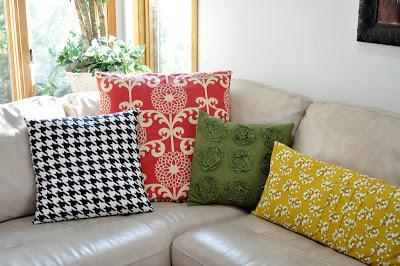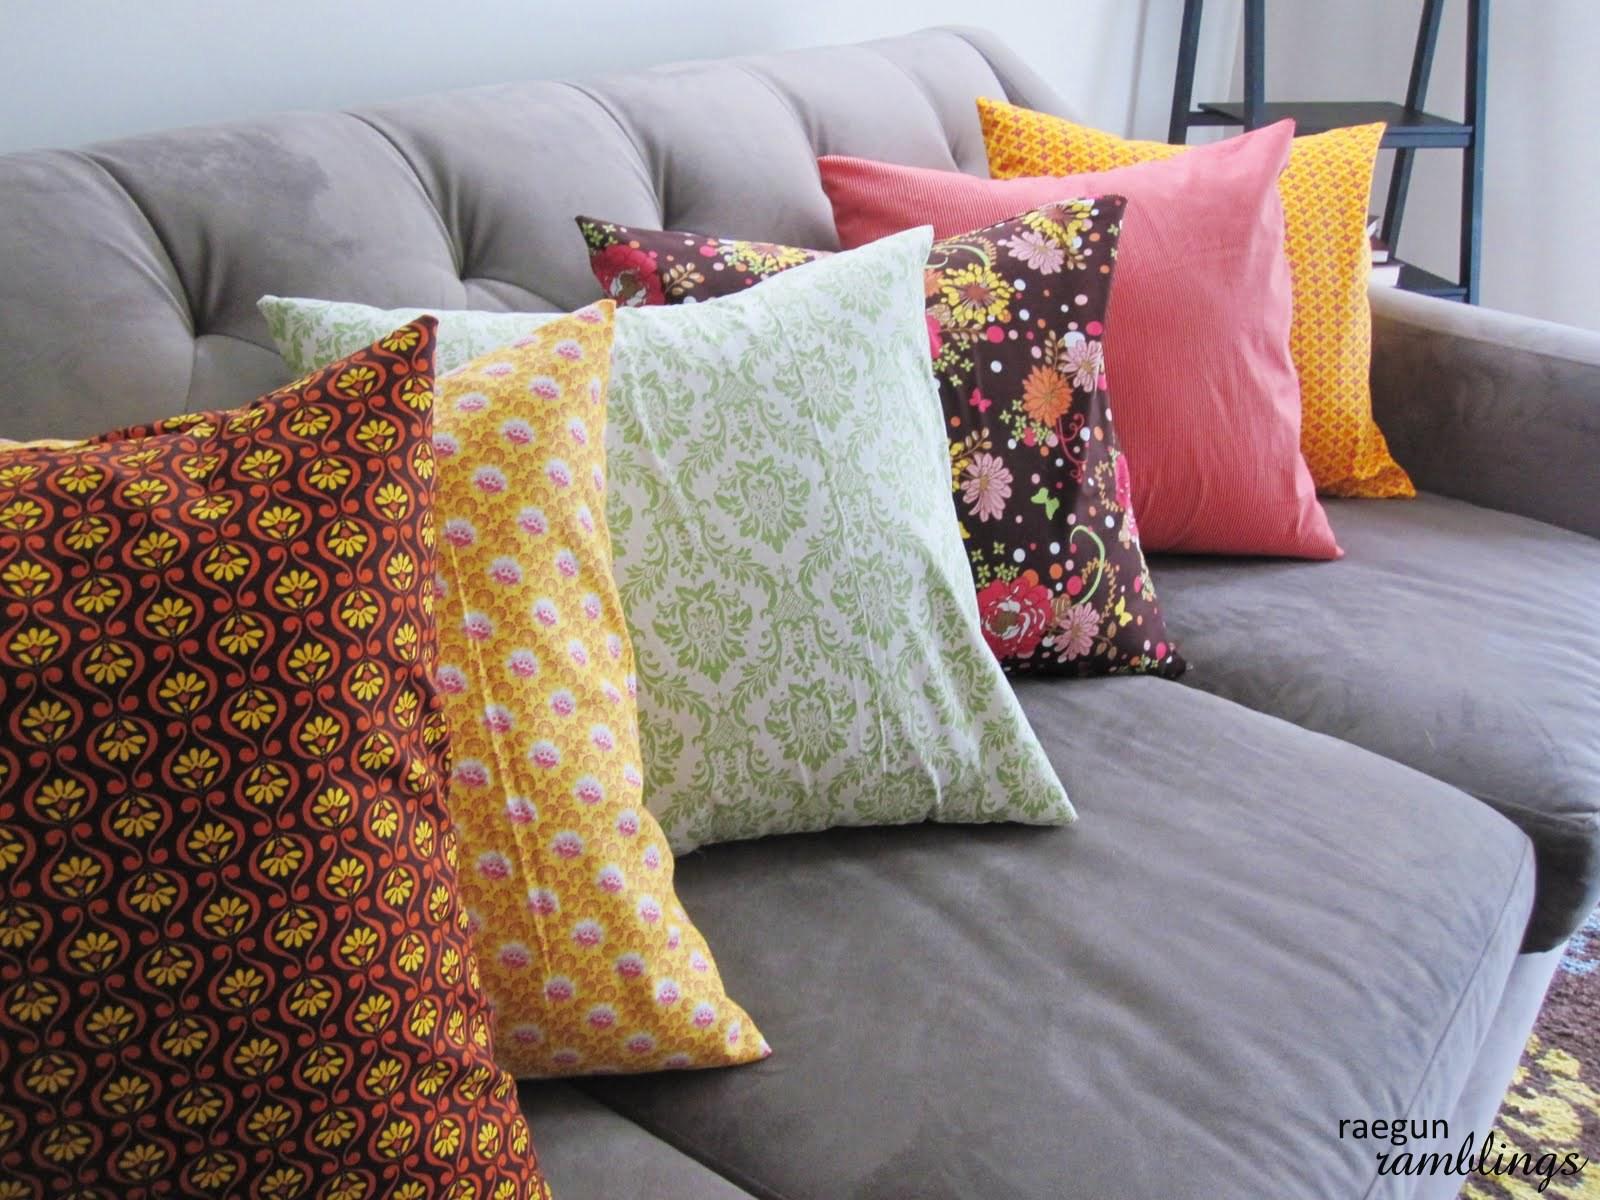The first image is the image on the left, the second image is the image on the right. Evaluate the accuracy of this statement regarding the images: "There are four different pillow sitting on a cream colored sofa.". Is it true? Answer yes or no. Yes. The first image is the image on the left, the second image is the image on the right. Examine the images to the left and right. Is the description "There are ten pillows total." accurate? Answer yes or no. Yes. 